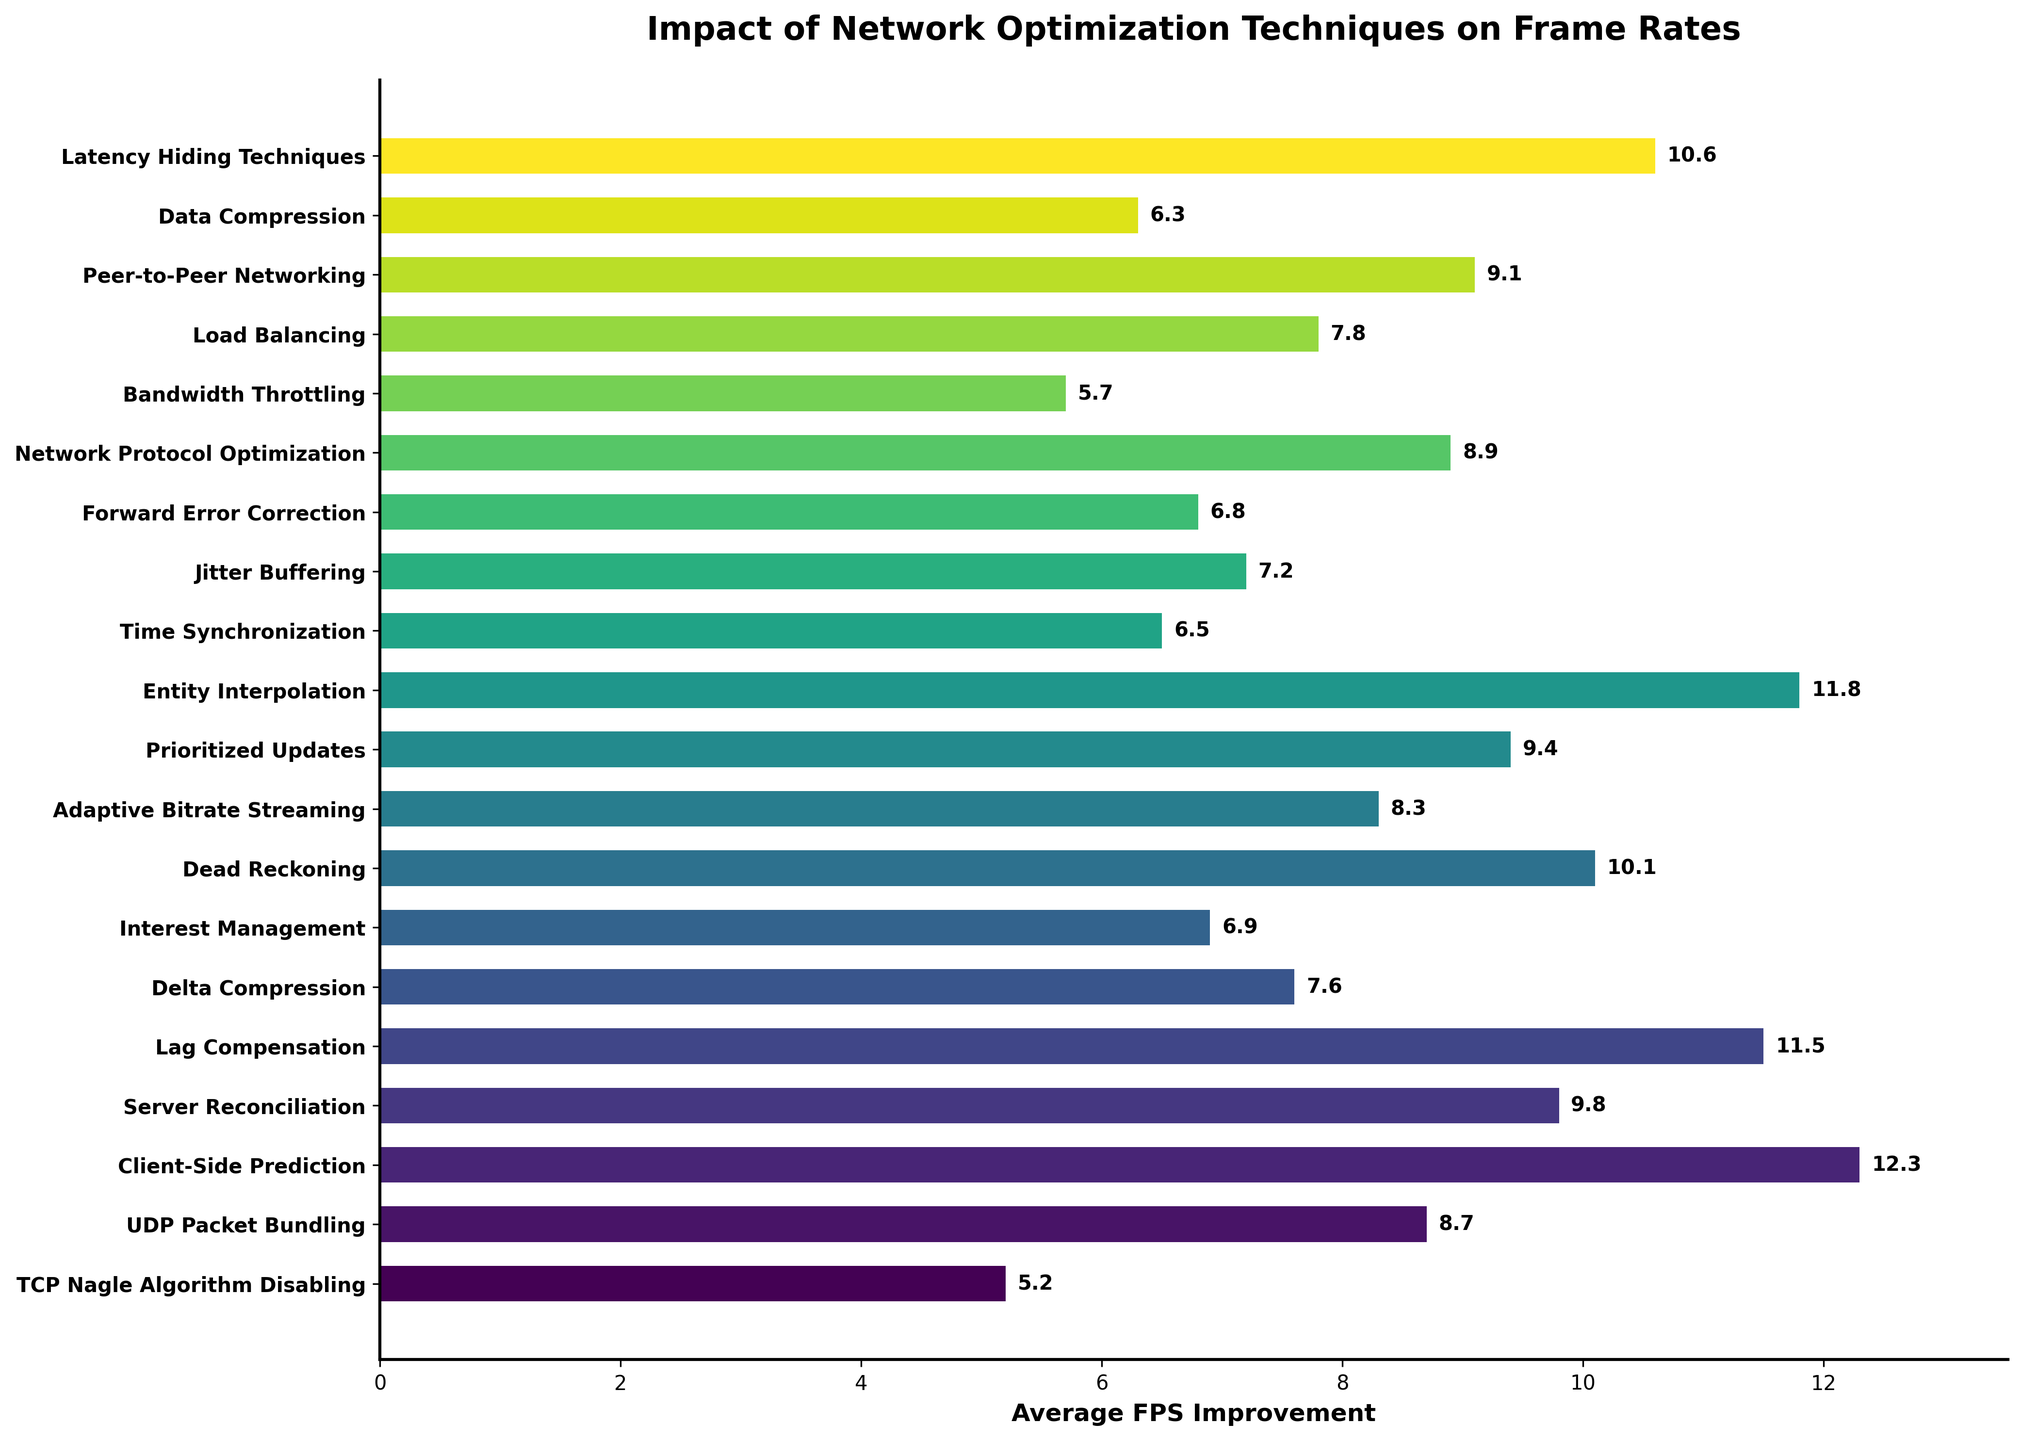Which network optimization technique has the highest average FPS improvement? The tooltips and labels indicate the values for each bar, and we find the tallest bar to be Client-Side Prediction with 12.3 average FPS improvement.
Answer: Client-Side Prediction Which two techniques have nearly the same impact on average FPS improvement? By examining the bars, we see that Entity Interpolation (11.8) and Lag Compensation (11.5) have very similar values.
Answer: Entity Interpolation and Lag Compensation What is the combined average FPS improvement of Delta Compression and Load Balancing? Delta Compression has 7.6 and Load Balancing has 7.8 average FPS improvement. Adding these together: 7.6 + 7.8 = 15.4.
Answer: 15.4 Which technique has a higher FPS improvement: Adaptive Bitrate Streaming or Network Protocol Optimization? Adaptive Bitrate Streaming is 8.3, while Network Protocol Optimization is 8.9. Thus, Network Protocol Optimization is higher.
Answer: Network Protocol Optimization What's the difference in average FPS improvement between Lag Compensation and Bandwidth Throttling? Lag Compensation has an improvement of 11.5, and Bandwidth Throttling has an improvement of 5.7. The difference is 11.5 - 5.7 = 5.8.
Answer: 5.8 Are there more techniques with an average FPS improvement above 10 or below 7? Counting the bars, there are 5 techniques (Client-Side Prediction, Lag Compensation, Dead Reckoning, Entity Interpolation, Latency Hiding Techniques) above 10, and 5 techniques (TCP Nagle Algorithm Disabling, Bandwidth Throttling, Time Synchronization, Data Compression, Forward Error Correction) below 7.
Answer: Equal number Which technique shows an average FPS improvement closest to 9? Viewing the bar lengths and values, Prioritized Updates has an improvement of 9.4 and Peer-to-Peer Networking has an improvement of 9.1; Peer-to-Peer Networking is closer to 9.
Answer: Peer-to-Peer Networking How many techniques yield an average FPS improvement of 11 or greater? By examining the bars, four techniques (Client-Side Prediction, Lag Compensation, Entity Interpolation, Latency Hiding Techniques) yield an improvement of 11 or greater.
Answer: Four techniques Which three techniques have the lowest average FPS improvement? By observing the shortest bars, TCP Nagle Algorithm Disabling (5.2), Bandwidth Throttling (5.7), and Data Compression (6.3) have the lowest values.
Answer: TCP Nagle Algorithm Disabling, Bandwidth Throttling, Data Compression 